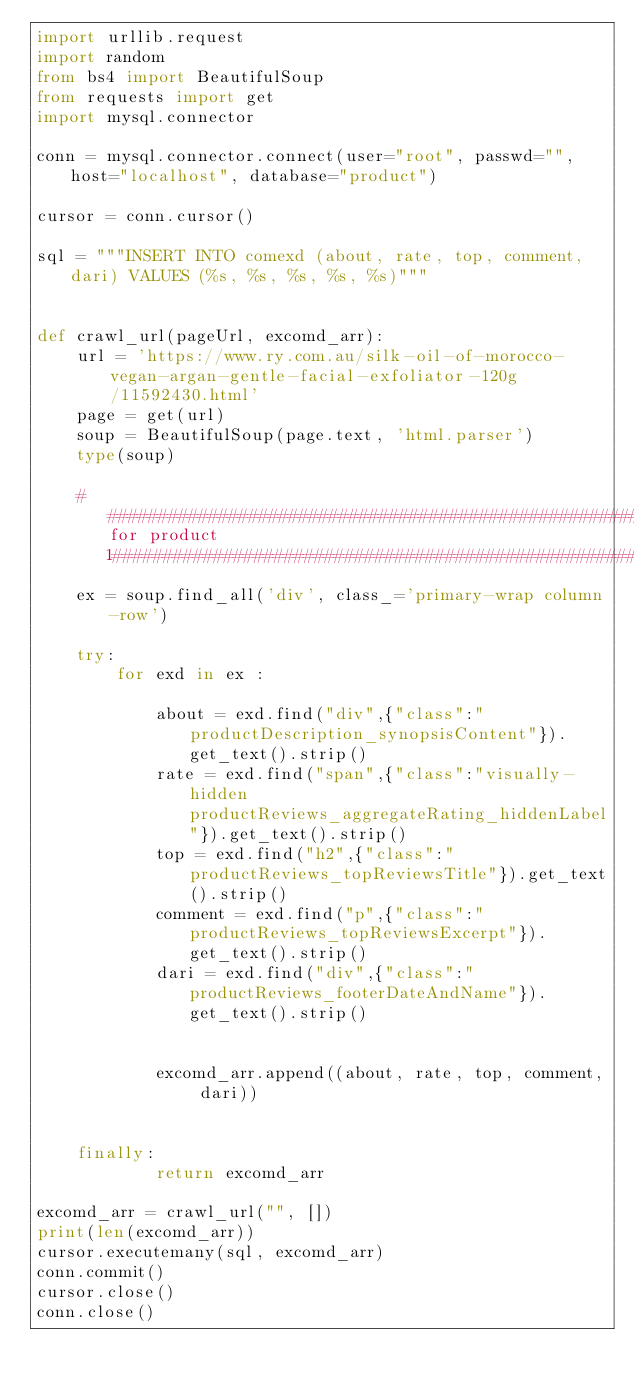<code> <loc_0><loc_0><loc_500><loc_500><_Python_>import urllib.request
import random
from bs4 import BeautifulSoup
from requests import get
import mysql.connector

conn = mysql.connector.connect(user="root", passwd="",host="localhost", database="product")

cursor = conn.cursor()

sql = """INSERT INTO comexd (about, rate, top, comment, dari) VALUES (%s, %s, %s, %s, %s)"""


def crawl_url(pageUrl, excomd_arr):
    url = 'https://www.ry.com.au/silk-oil-of-morocco-vegan-argan-gentle-facial-exfoliator-120g/11592430.html'
    page = get(url)
    soup = BeautifulSoup(page.text, 'html.parser')
    type(soup)

    #######################################################for product 1############################################################################
    ex = soup.find_all('div', class_='primary-wrap column-row')

    try:
        for exd in ex :

            about = exd.find("div",{"class":"productDescription_synopsisContent"}).get_text().strip()
            rate = exd.find("span",{"class":"visually-hidden productReviews_aggregateRating_hiddenLabel"}).get_text().strip()
            top = exd.find("h2",{"class":"productReviews_topReviewsTitle"}).get_text().strip()
            comment = exd.find("p",{"class":"productReviews_topReviewsExcerpt"}).get_text().strip()
            dari = exd.find("div",{"class":"productReviews_footerDateAndName"}).get_text().strip()


            excomd_arr.append((about, rate, top, comment, dari))


    finally:
            return excomd_arr

excomd_arr = crawl_url("", [])
print(len(excomd_arr))
cursor.executemany(sql, excomd_arr)
conn.commit()
cursor.close()
conn.close()
</code> 